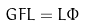Convert formula to latex. <formula><loc_0><loc_0><loc_500><loc_500>G F L = L \Phi</formula> 